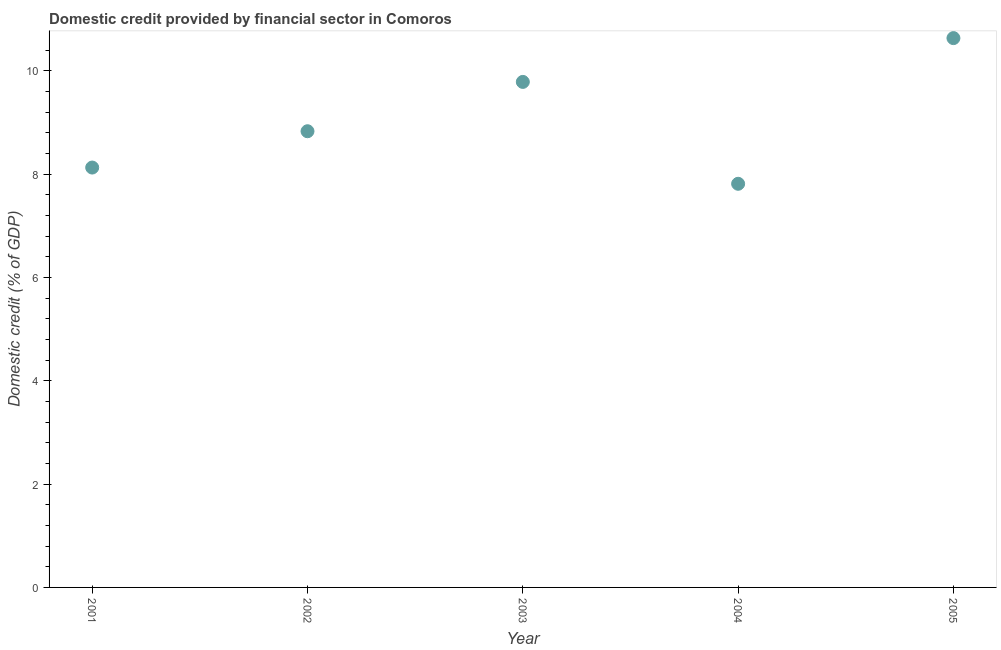What is the domestic credit provided by financial sector in 2003?
Your response must be concise. 9.78. Across all years, what is the maximum domestic credit provided by financial sector?
Offer a terse response. 10.63. Across all years, what is the minimum domestic credit provided by financial sector?
Offer a very short reply. 7.81. What is the sum of the domestic credit provided by financial sector?
Provide a short and direct response. 45.18. What is the difference between the domestic credit provided by financial sector in 2002 and 2005?
Keep it short and to the point. -1.8. What is the average domestic credit provided by financial sector per year?
Ensure brevity in your answer.  9.04. What is the median domestic credit provided by financial sector?
Give a very brief answer. 8.83. Do a majority of the years between 2002 and 2001 (inclusive) have domestic credit provided by financial sector greater than 4.8 %?
Offer a very short reply. No. What is the ratio of the domestic credit provided by financial sector in 2001 to that in 2004?
Your response must be concise. 1.04. Is the domestic credit provided by financial sector in 2001 less than that in 2003?
Keep it short and to the point. Yes. Is the difference between the domestic credit provided by financial sector in 2002 and 2003 greater than the difference between any two years?
Offer a very short reply. No. What is the difference between the highest and the second highest domestic credit provided by financial sector?
Your response must be concise. 0.85. What is the difference between the highest and the lowest domestic credit provided by financial sector?
Your answer should be compact. 2.82. In how many years, is the domestic credit provided by financial sector greater than the average domestic credit provided by financial sector taken over all years?
Your answer should be very brief. 2. Does the domestic credit provided by financial sector monotonically increase over the years?
Provide a short and direct response. No. How many dotlines are there?
Give a very brief answer. 1. Are the values on the major ticks of Y-axis written in scientific E-notation?
Your answer should be very brief. No. Does the graph contain any zero values?
Your answer should be very brief. No. Does the graph contain grids?
Ensure brevity in your answer.  No. What is the title of the graph?
Keep it short and to the point. Domestic credit provided by financial sector in Comoros. What is the label or title of the X-axis?
Provide a short and direct response. Year. What is the label or title of the Y-axis?
Give a very brief answer. Domestic credit (% of GDP). What is the Domestic credit (% of GDP) in 2001?
Offer a terse response. 8.13. What is the Domestic credit (% of GDP) in 2002?
Your answer should be very brief. 8.83. What is the Domestic credit (% of GDP) in 2003?
Make the answer very short. 9.78. What is the Domestic credit (% of GDP) in 2004?
Make the answer very short. 7.81. What is the Domestic credit (% of GDP) in 2005?
Offer a terse response. 10.63. What is the difference between the Domestic credit (% of GDP) in 2001 and 2002?
Offer a terse response. -0.7. What is the difference between the Domestic credit (% of GDP) in 2001 and 2003?
Offer a very short reply. -1.66. What is the difference between the Domestic credit (% of GDP) in 2001 and 2004?
Provide a succinct answer. 0.31. What is the difference between the Domestic credit (% of GDP) in 2001 and 2005?
Make the answer very short. -2.5. What is the difference between the Domestic credit (% of GDP) in 2002 and 2003?
Offer a terse response. -0.95. What is the difference between the Domestic credit (% of GDP) in 2002 and 2004?
Provide a succinct answer. 1.02. What is the difference between the Domestic credit (% of GDP) in 2002 and 2005?
Provide a succinct answer. -1.8. What is the difference between the Domestic credit (% of GDP) in 2003 and 2004?
Provide a succinct answer. 1.97. What is the difference between the Domestic credit (% of GDP) in 2003 and 2005?
Give a very brief answer. -0.85. What is the difference between the Domestic credit (% of GDP) in 2004 and 2005?
Give a very brief answer. -2.82. What is the ratio of the Domestic credit (% of GDP) in 2001 to that in 2002?
Make the answer very short. 0.92. What is the ratio of the Domestic credit (% of GDP) in 2001 to that in 2003?
Your answer should be very brief. 0.83. What is the ratio of the Domestic credit (% of GDP) in 2001 to that in 2004?
Your response must be concise. 1.04. What is the ratio of the Domestic credit (% of GDP) in 2001 to that in 2005?
Your answer should be compact. 0.76. What is the ratio of the Domestic credit (% of GDP) in 2002 to that in 2003?
Provide a short and direct response. 0.9. What is the ratio of the Domestic credit (% of GDP) in 2002 to that in 2004?
Provide a short and direct response. 1.13. What is the ratio of the Domestic credit (% of GDP) in 2002 to that in 2005?
Provide a short and direct response. 0.83. What is the ratio of the Domestic credit (% of GDP) in 2003 to that in 2004?
Your answer should be compact. 1.25. What is the ratio of the Domestic credit (% of GDP) in 2004 to that in 2005?
Keep it short and to the point. 0.73. 